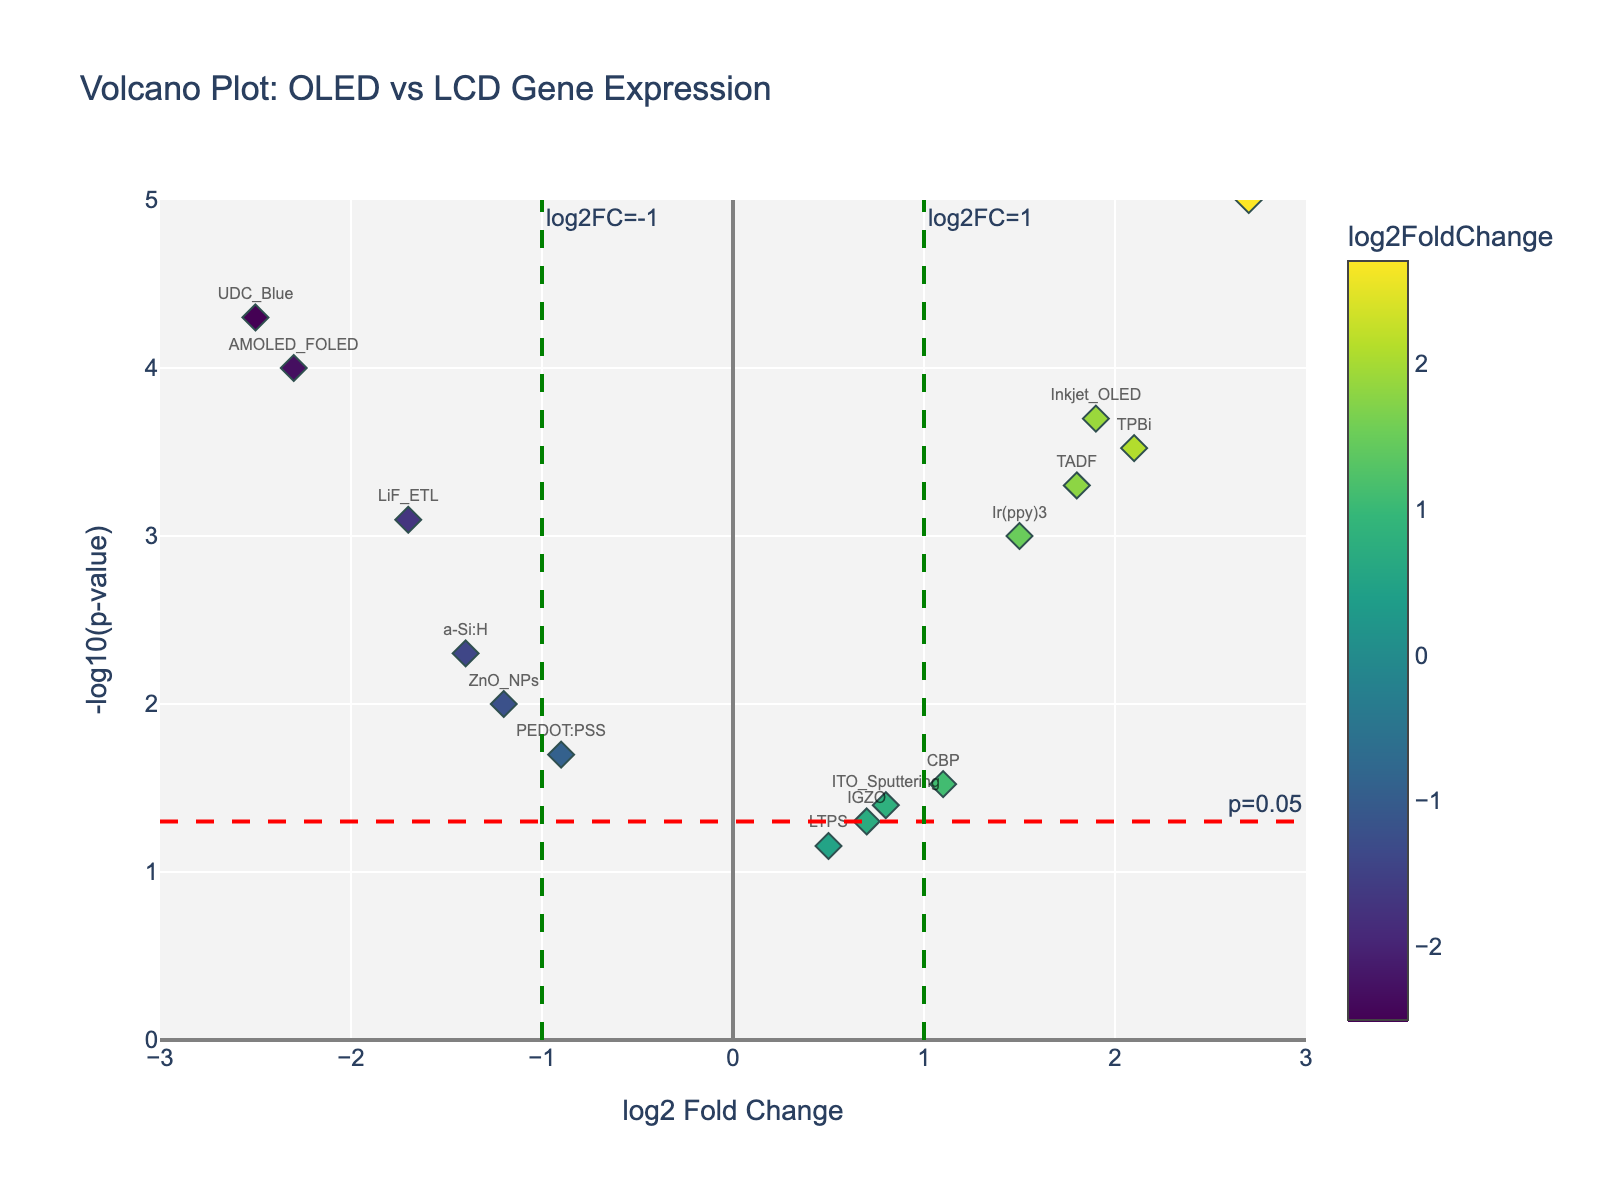What is the gene with the highest log2 fold change? To determine this, look for the gene positioned furthest to the right on the x-axis as this represents the highest log2 fold change. The gene "QD_Red" has the highest log2 fold change of 2.7.
Answer: QD_Red What are the titles of the axes on the plot? The x-axis and y-axis titles can be found by looking at the labels on the horizontal and vertical axes respectively. They are "log2 Fold Change" for the x-axis and "-log10(p-value)" for the y-axis.
Answer: log2 Fold Change and -log10(p-value) Which gene has the lowest p-value? The lowest p-value corresponds to the highest value on the y-axis because -log10(p-value) transforms smaller p-values into larger positive values. "QD_Red" has the highest -log10(p-value), which is approximately 5, indicating the lowest p-value.
Answer: QD_Red How many genes have a log2 fold change greater than 1? Identify the points lying to the right of the vertical line x=1. These points represent genes with a log2 fold change greater than 1. The genes are "TADF", "TPBi", "Ir(ppy)3", "QD_Red", and "Inkjet_OLED". So there are 5 genes.
Answer: 5 Which genes are significantly upregulated (log2FC > 1 and p-value < 0.05)? Significantly upregulated genes lie to the right of the vertical line x=1 and above the horizontal line y=-log10(0.05). These genes are "TADF", "TPBi", "QD_Red", and "Inkjet_OLED".
Answer: TADF, TPBi, QD_Red, Inkjet_OLED What does the red horizontal line represent in terms of p-value? The red horizontal line is annotated with "p=0.05", indicating it represents a p-value threshold of 0.05. This is a common significance level in biological studies, meaning points above this line are statistically significant.
Answer: p=0.05 threshold How many genes are positioned on the left side of the x-axis, indicating negative changes? Genes with negative log2 fold changes appear on the left side of the vertical line x=0. By counting these, we find "AMOLED_FOLED", "PEDOT:PSS", "ZnO_NPs", "LiF_ETL", "UDC_Blue", and "a-Si:H". This totals to 6 genes.
Answer: 6 Which genes have both their log2 fold change values less than -1 and p-values less than 0.05? Look for genes to the left of the vertical line x=-1 and above the horizontal line y=-log10(0.05). These genes are "AMOLED_FOLED", "LiF_ETL", and "UDC_Blue".
Answer: AMOLED_FOLED, LiF_ETL, UDC_Blue What is the log2 fold change and p-value for the gene "a-Si:H"? Refer to the plot and find the position for the gene "a-Si:H". The log2 fold change for "a-Si:H" is approximately -1.4, and the p-value is 0.005 as plotted.
Answer: -1.4 and 0.005 